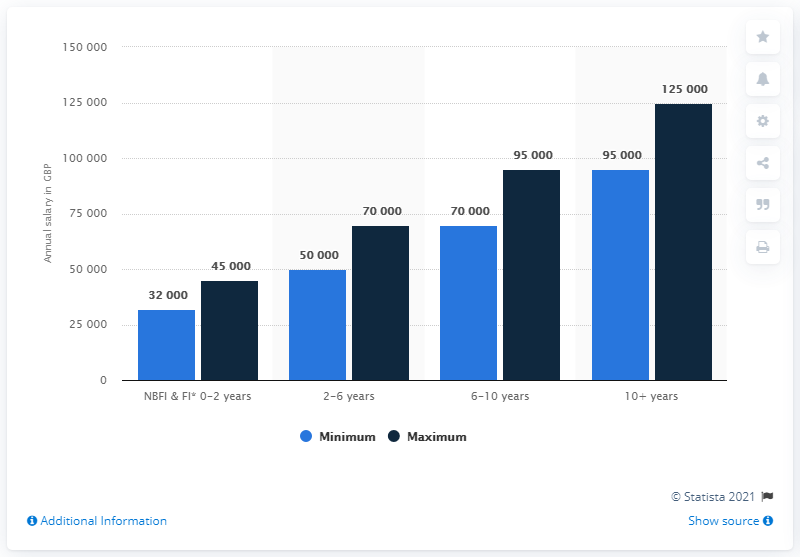Point out several critical features in this image. The difference in annual minimum and maximum salary for those with 2-6 years of experience in the service industry is $20,000. Based on 10 years of experience in the service industry, the maximum annual salary that can be earned is $125,000. 